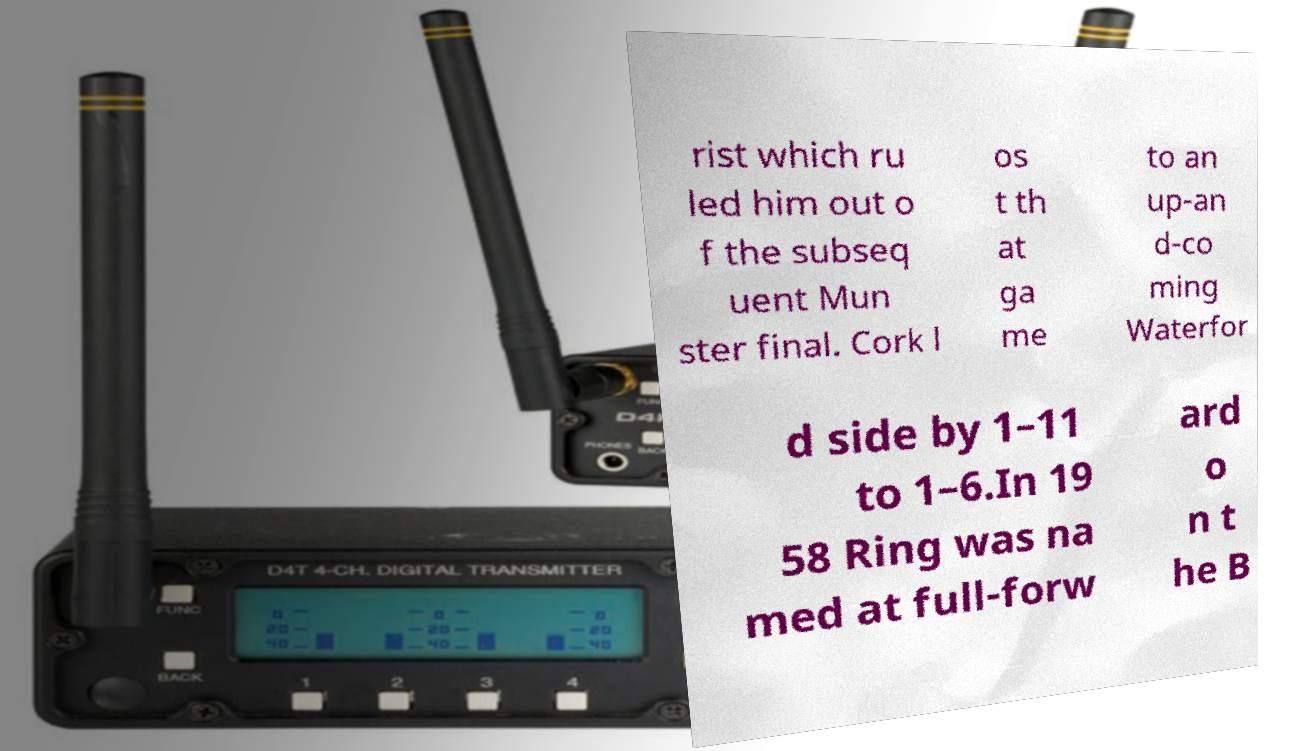I need the written content from this picture converted into text. Can you do that? rist which ru led him out o f the subseq uent Mun ster final. Cork l os t th at ga me to an up-an d-co ming Waterfor d side by 1–11 to 1–6.In 19 58 Ring was na med at full-forw ard o n t he B 